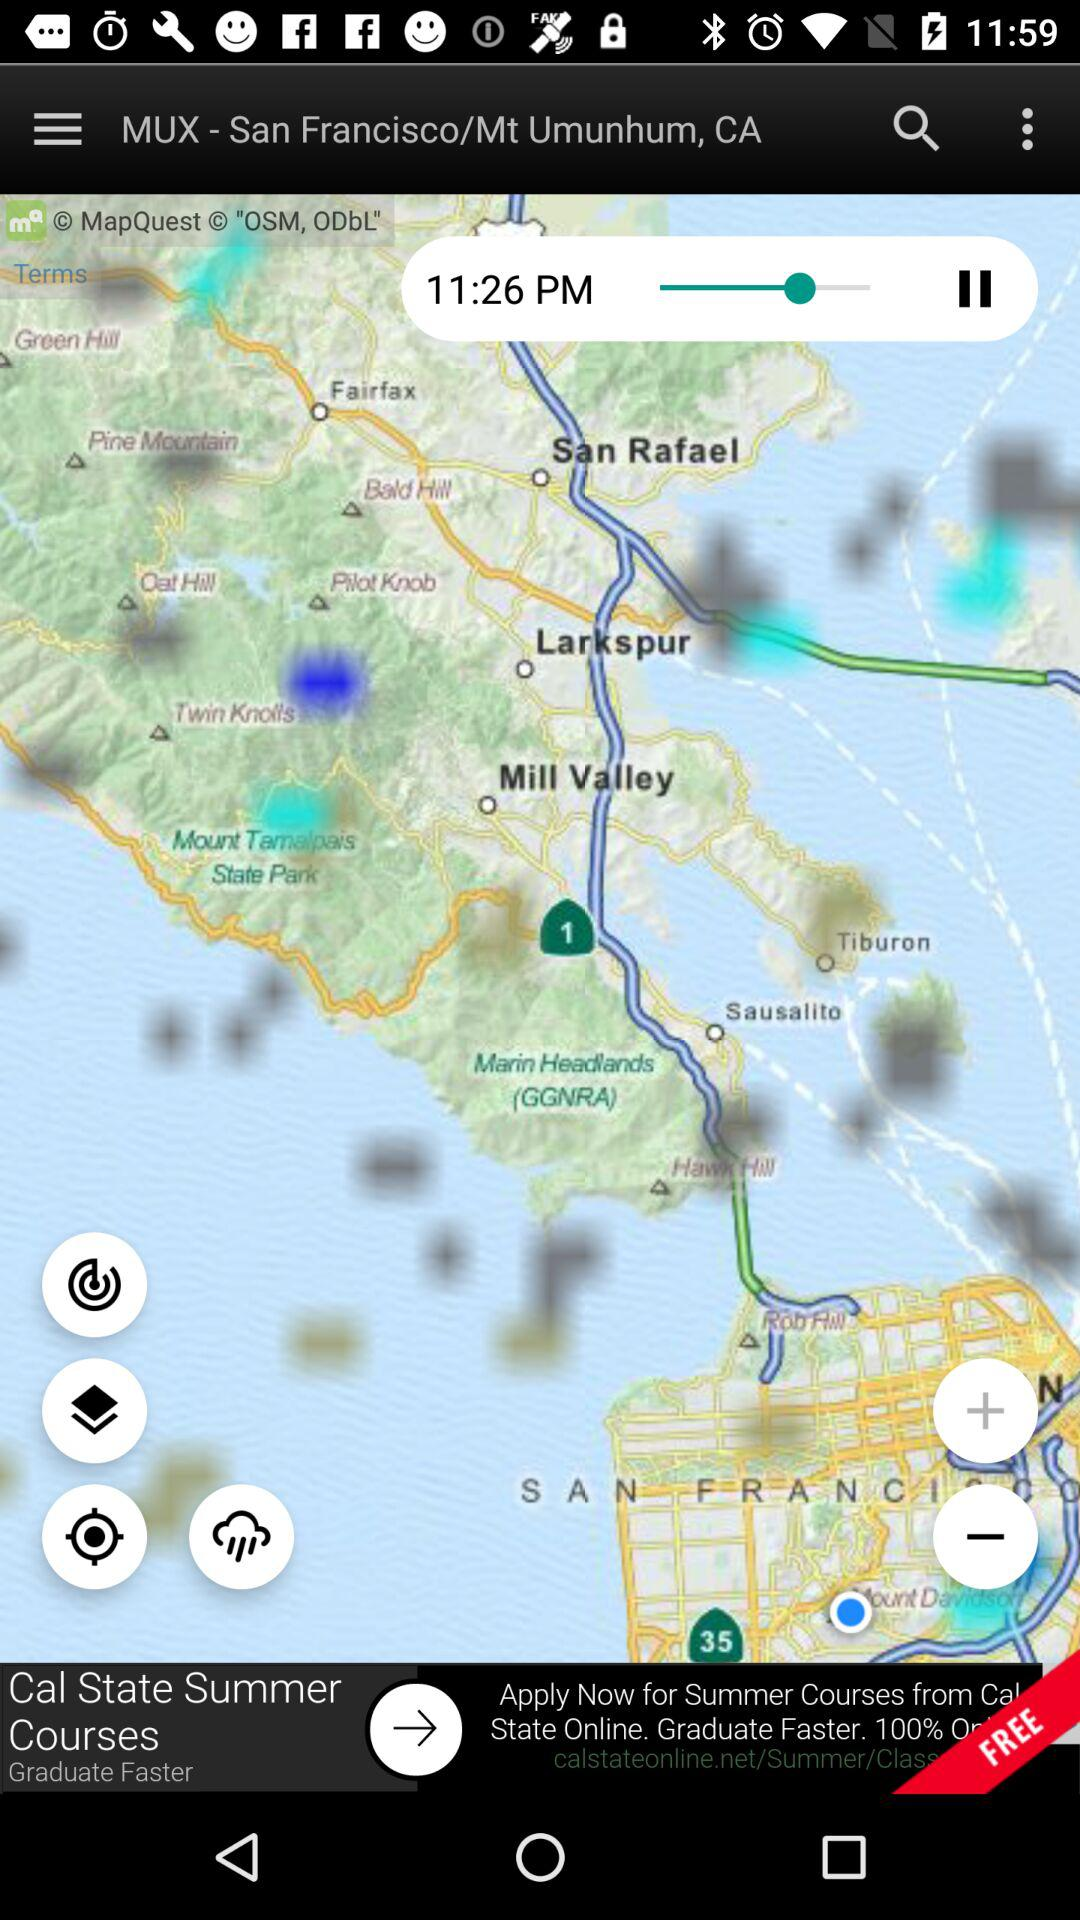What is the time? The time is 11:26 PM. 